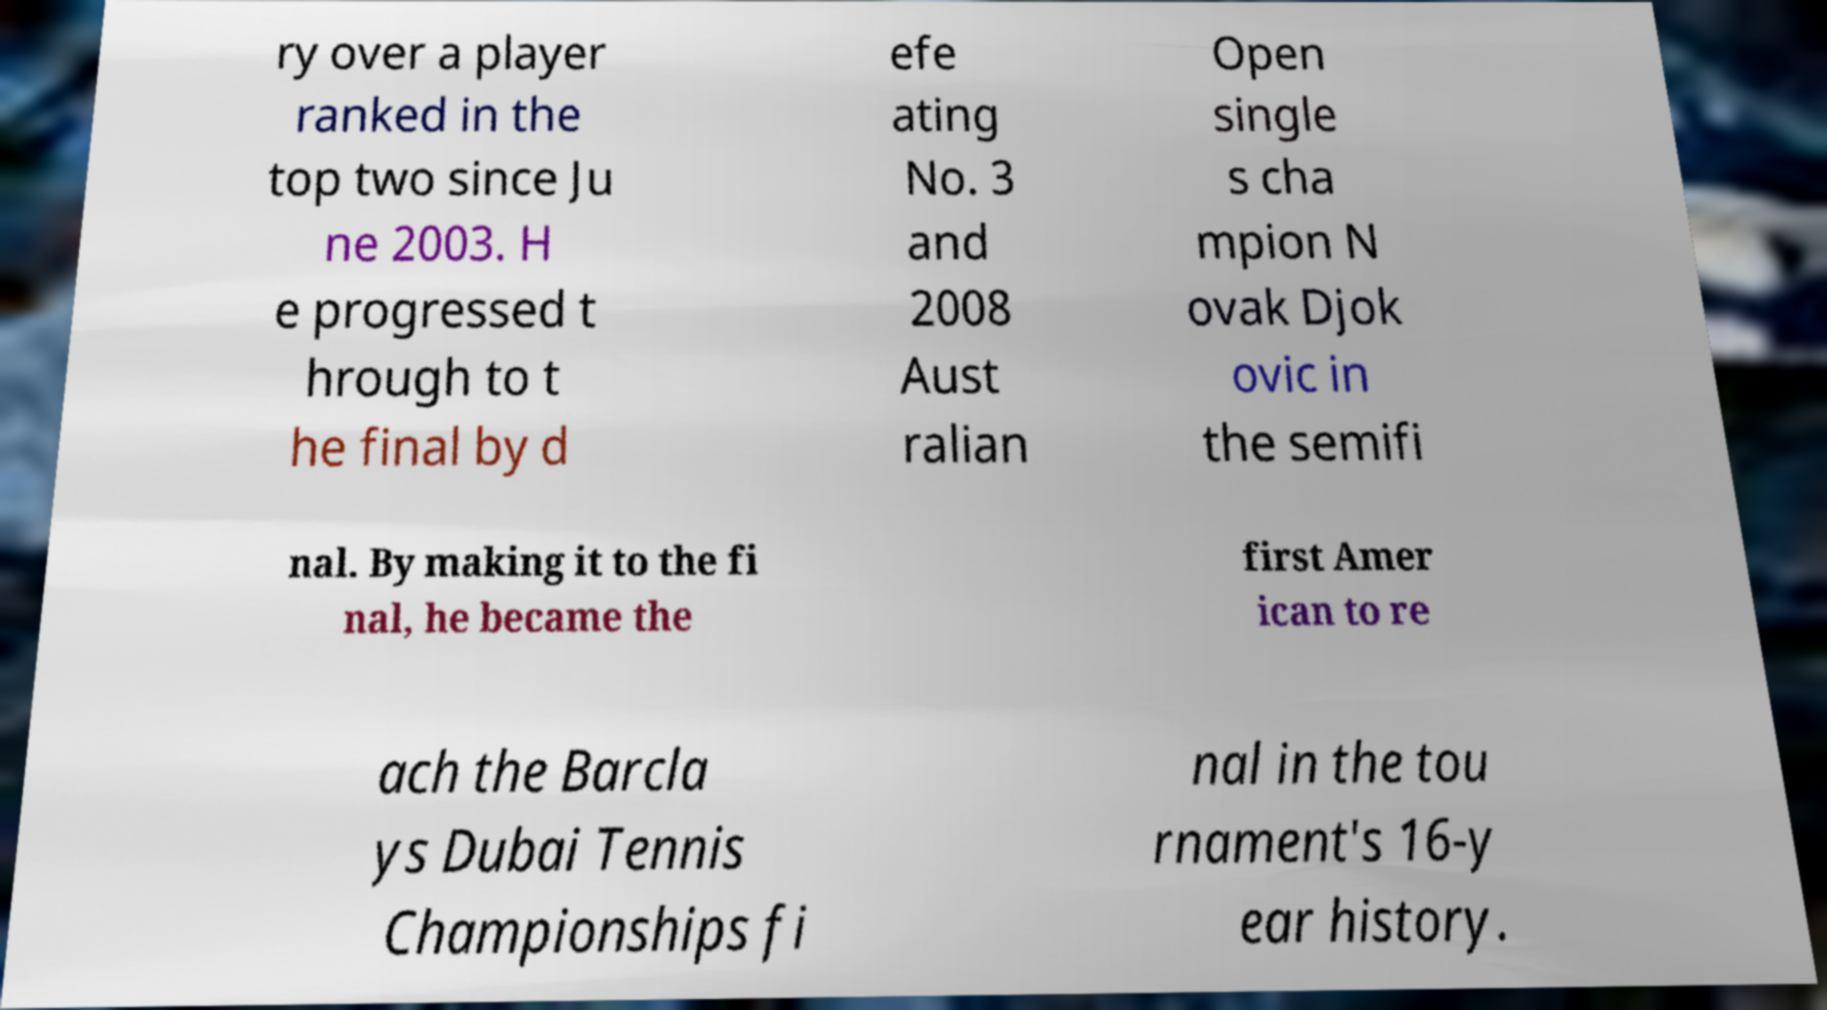Could you assist in decoding the text presented in this image and type it out clearly? ry over a player ranked in the top two since Ju ne 2003. H e progressed t hrough to t he final by d efe ating No. 3 and 2008 Aust ralian Open single s cha mpion N ovak Djok ovic in the semifi nal. By making it to the fi nal, he became the first Amer ican to re ach the Barcla ys Dubai Tennis Championships fi nal in the tou rnament's 16-y ear history. 